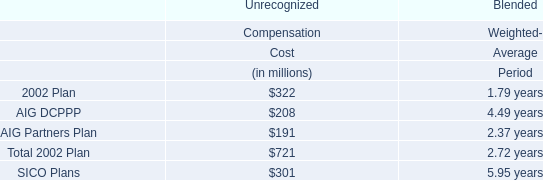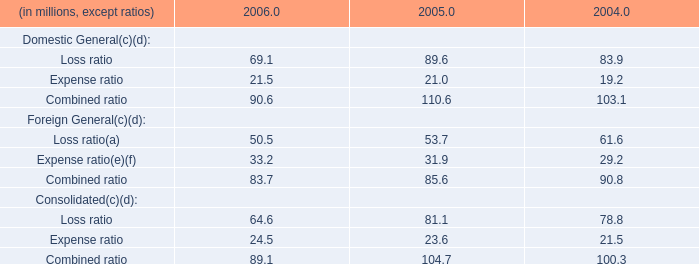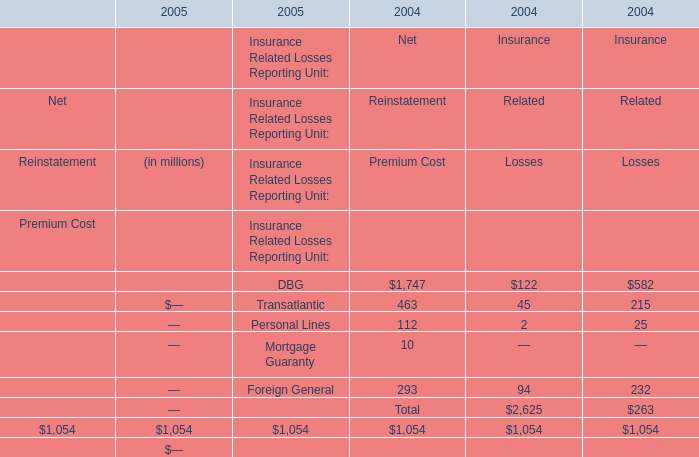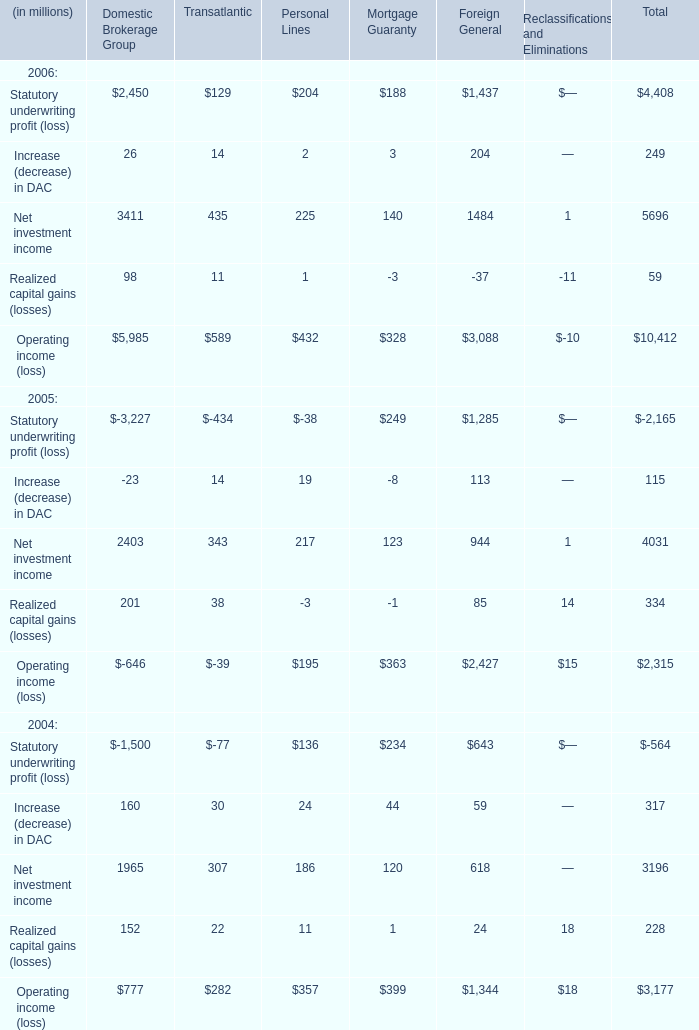In the year with lowest amount of Loss ratio of Consolidated in table 1, what's the increasing rate of Expense ratio of Consolidated in table 1? 
Computations: ((24.5 - 23.6) / 23.6)
Answer: 0.03814. 